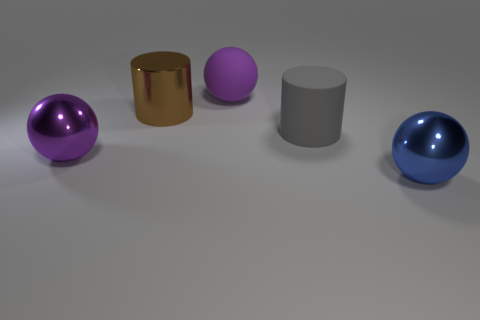Add 1 brown metallic cylinders. How many objects exist? 6 Subtract all cylinders. How many objects are left? 3 Subtract 0 red spheres. How many objects are left? 5 Subtract all brown shiny objects. Subtract all blue shiny spheres. How many objects are left? 3 Add 3 large spheres. How many large spheres are left? 6 Add 5 cyan shiny cubes. How many cyan shiny cubes exist? 5 